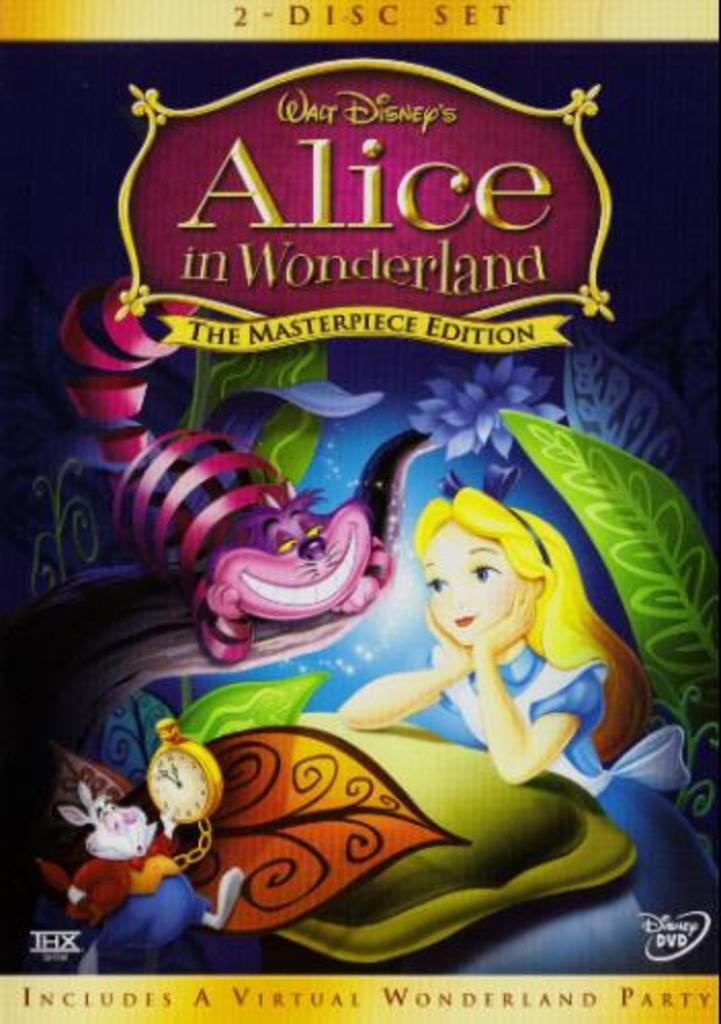What is the name of the movie?
Offer a very short reply. Alice in wonderland. 